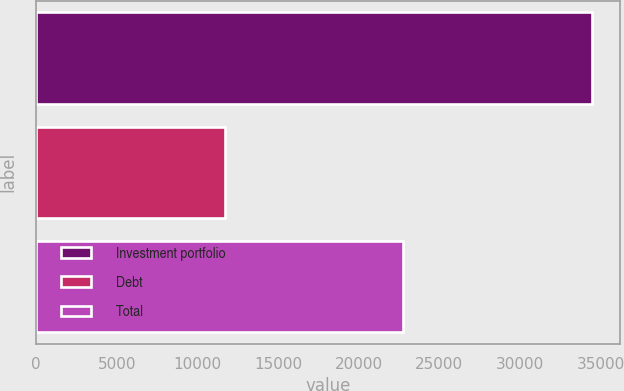Convert chart to OTSL. <chart><loc_0><loc_0><loc_500><loc_500><bar_chart><fcel>Investment portfolio<fcel>Debt<fcel>Total<nl><fcel>34478<fcel>11724<fcel>22754<nl></chart> 